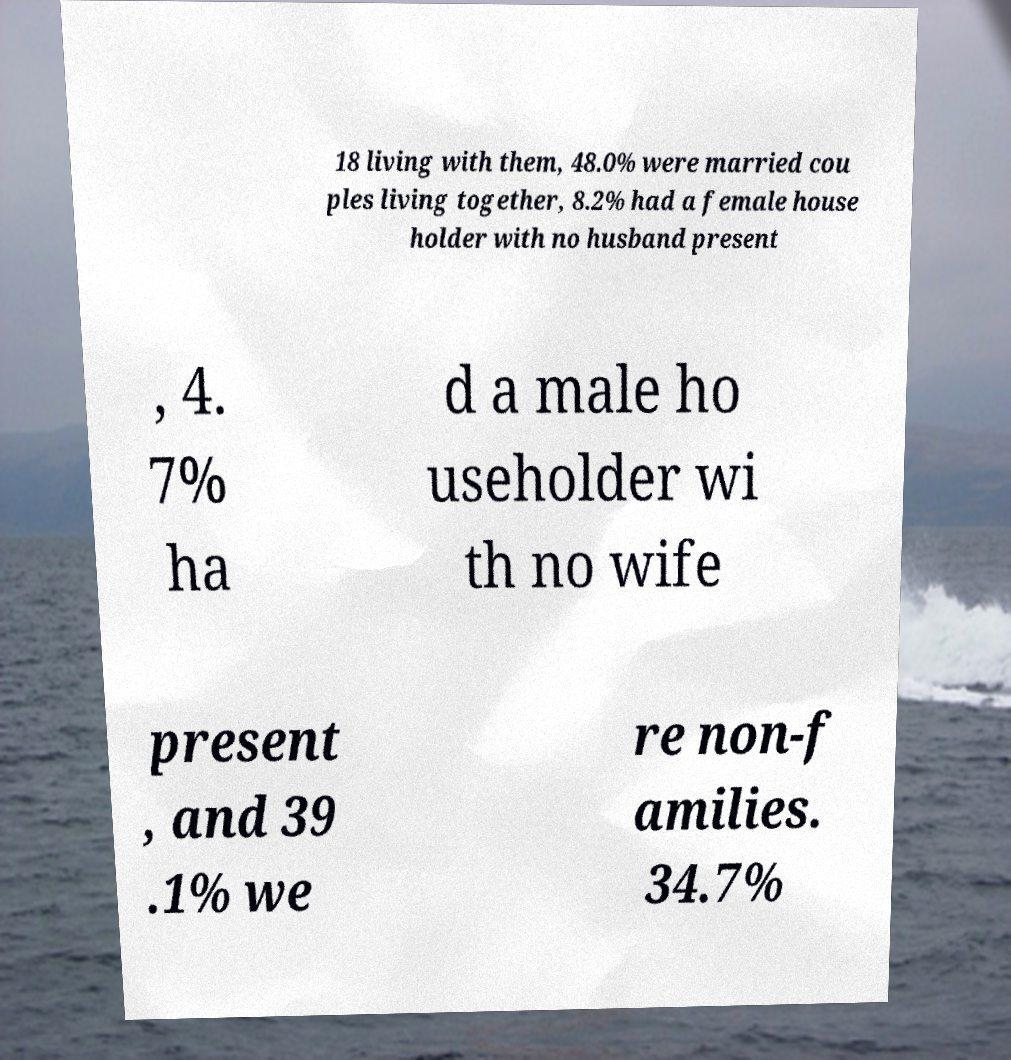Could you assist in decoding the text presented in this image and type it out clearly? 18 living with them, 48.0% were married cou ples living together, 8.2% had a female house holder with no husband present , 4. 7% ha d a male ho useholder wi th no wife present , and 39 .1% we re non-f amilies. 34.7% 